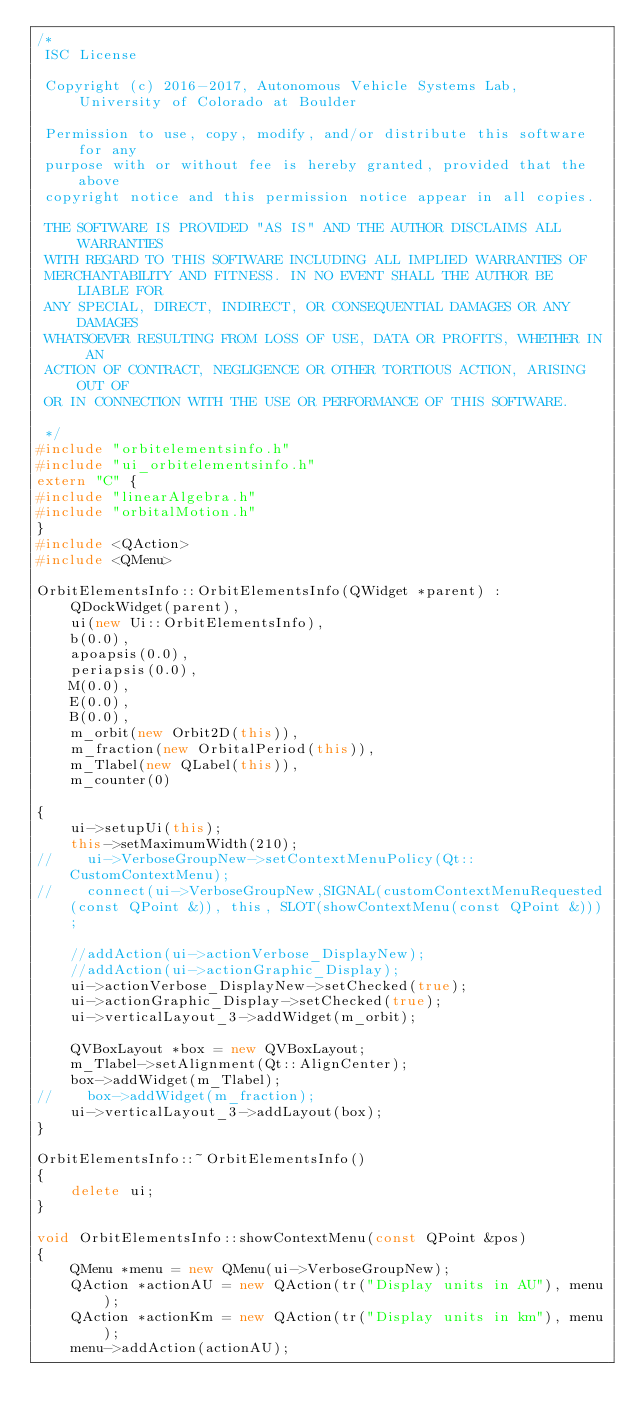<code> <loc_0><loc_0><loc_500><loc_500><_C++_>/*
 ISC License

 Copyright (c) 2016-2017, Autonomous Vehicle Systems Lab, University of Colorado at Boulder

 Permission to use, copy, modify, and/or distribute this software for any
 purpose with or without fee is hereby granted, provided that the above
 copyright notice and this permission notice appear in all copies.

 THE SOFTWARE IS PROVIDED "AS IS" AND THE AUTHOR DISCLAIMS ALL WARRANTIES
 WITH REGARD TO THIS SOFTWARE INCLUDING ALL IMPLIED WARRANTIES OF
 MERCHANTABILITY AND FITNESS. IN NO EVENT SHALL THE AUTHOR BE LIABLE FOR
 ANY SPECIAL, DIRECT, INDIRECT, OR CONSEQUENTIAL DAMAGES OR ANY DAMAGES
 WHATSOEVER RESULTING FROM LOSS OF USE, DATA OR PROFITS, WHETHER IN AN
 ACTION OF CONTRACT, NEGLIGENCE OR OTHER TORTIOUS ACTION, ARISING OUT OF
 OR IN CONNECTION WITH THE USE OR PERFORMANCE OF THIS SOFTWARE.

 */
#include "orbitelementsinfo.h"
#include "ui_orbitelementsinfo.h"
extern "C" {
#include "linearAlgebra.h"
#include "orbitalMotion.h"
}
#include <QAction>
#include <QMenu>

OrbitElementsInfo::OrbitElementsInfo(QWidget *parent) :
    QDockWidget(parent),
    ui(new Ui::OrbitElementsInfo),
    b(0.0),
    apoapsis(0.0),
    periapsis(0.0),
    M(0.0),
    E(0.0),
    B(0.0),
    m_orbit(new Orbit2D(this)),
    m_fraction(new OrbitalPeriod(this)),
    m_Tlabel(new QLabel(this)),
    m_counter(0)

{
    ui->setupUi(this);
    this->setMaximumWidth(210);
//    ui->VerboseGroupNew->setContextMenuPolicy(Qt::CustomContextMenu);
//    connect(ui->VerboseGroupNew,SIGNAL(customContextMenuRequested(const QPoint &)), this, SLOT(showContextMenu(const QPoint &)));
    
    //addAction(ui->actionVerbose_DisplayNew);
    //addAction(ui->actionGraphic_Display);
    ui->actionVerbose_DisplayNew->setChecked(true);
    ui->actionGraphic_Display->setChecked(true);
    ui->verticalLayout_3->addWidget(m_orbit);
    
    QVBoxLayout *box = new QVBoxLayout;
    m_Tlabel->setAlignment(Qt::AlignCenter);
    box->addWidget(m_Tlabel);
//    box->addWidget(m_fraction);
    ui->verticalLayout_3->addLayout(box);
}

OrbitElementsInfo::~OrbitElementsInfo()
{
    delete ui;
}

void OrbitElementsInfo::showContextMenu(const QPoint &pos)
{
    QMenu *menu = new QMenu(ui->VerboseGroupNew);
    QAction *actionAU = new QAction(tr("Display units in AU"), menu);
    QAction *actionKm = new QAction(tr("Display units in km"), menu);
    menu->addAction(actionAU);</code> 